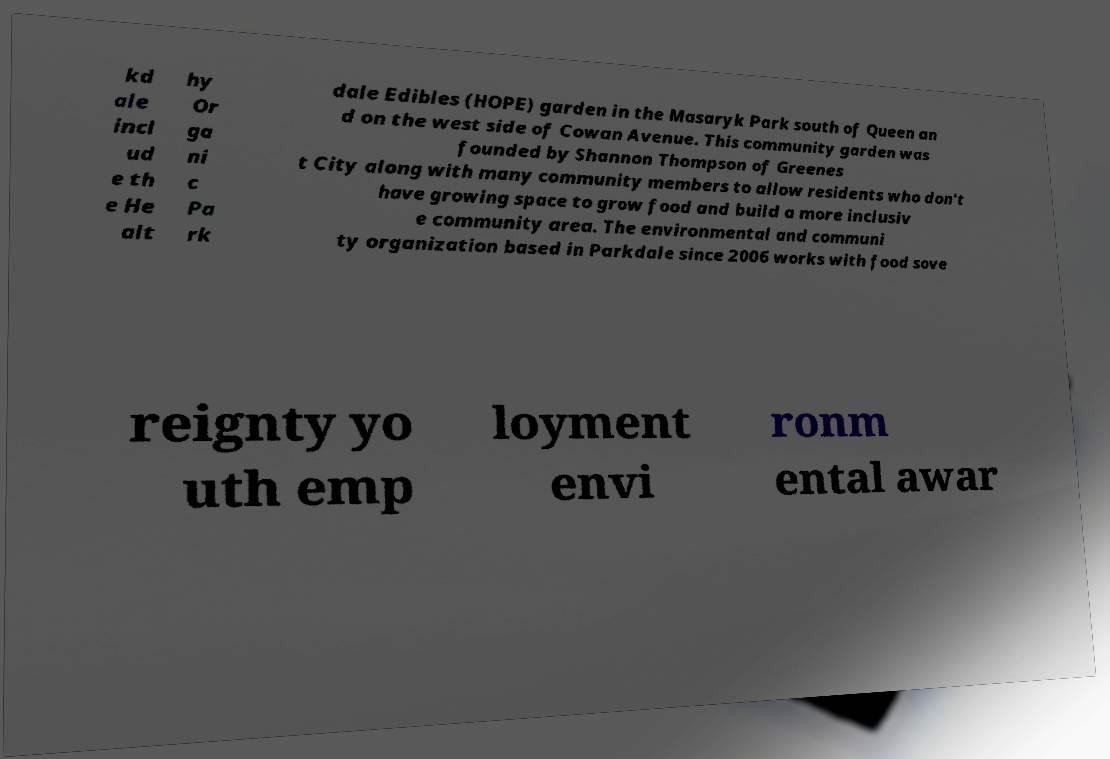Can you read and provide the text displayed in the image?This photo seems to have some interesting text. Can you extract and type it out for me? kd ale incl ud e th e He alt hy Or ga ni c Pa rk dale Edibles (HOPE) garden in the Masaryk Park south of Queen an d on the west side of Cowan Avenue. This community garden was founded by Shannon Thompson of Greenes t City along with many community members to allow residents who don't have growing space to grow food and build a more inclusiv e community area. The environmental and communi ty organization based in Parkdale since 2006 works with food sove reignty yo uth emp loyment envi ronm ental awar 